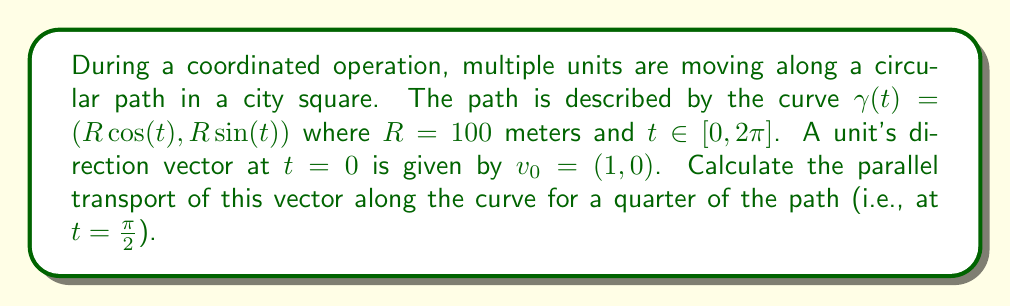Show me your answer to this math problem. To solve this problem, we'll follow these steps:

1) First, we need to calculate the tangent vector to the curve:
   $$T(t) = \gamma'(t) = (-R\sin(t), R\cos(t))$$

2) The normal vector is perpendicular to the tangent vector:
   $$N(t) = (-\cos(t), -\sin(t))$$

3) For a curve in $\mathbb{R}^2$, the parallel transport of a vector $v(t)$ along the curve satisfies:
   $$\frac{dv}{dt} = -\left(\frac{dv}{dt} \cdot N\right)T$$

4) We can express $v(t)$ in terms of its components along $T$ and $N$:
   $$v(t) = a(t)T(t) + b(t)N(t)$$

5) The condition for parallel transport implies that $b(t)$ is constant. Let's call this constant $b_0$.

6) At $t=0$, we have:
   $$v_0 = (1,0) = a(0)T(0) + b_0N(0) = a(0)(0,1) + b_0(-1,0)$$
   This implies $a(0) = 0$ and $b_0 = -1$

7) Therefore, the parallel transport of $v_0$ along the curve is:
   $$v(t) = a(t)(-R\sin(t), R\cos(t)) + (-1)(-\cos(t), -\sin(t))$$
   $$= (-a(t)R\sin(t), a(t)R\cos(t)) + (\cos(t), \sin(t))$$

8) At $t = \frac{\pi}{2}$:
   $$v(\frac{\pi}{2}) = (-a(\frac{\pi}{2})R, 0) + (0, 1) = (-a(\frac{\pi}{2})R, 1)$$

9) To find $a(\frac{\pi}{2})$, we use the fact that parallel transport preserves the length of vectors:
   $$\|v(\frac{\pi}{2})\|^2 = \|v_0\|^2 = 1$$
   $$(a(\frac{\pi}{2})R)^2 + 1^2 = 1^2$$
   $$a(\frac{\pi}{2}) = 0$$

10) Therefore, the parallel transport of $v_0$ at $t = \frac{\pi}{2}$ is:
    $$v(\frac{\pi}{2}) = (0, 1)$$
Answer: $(0, 1)$ 